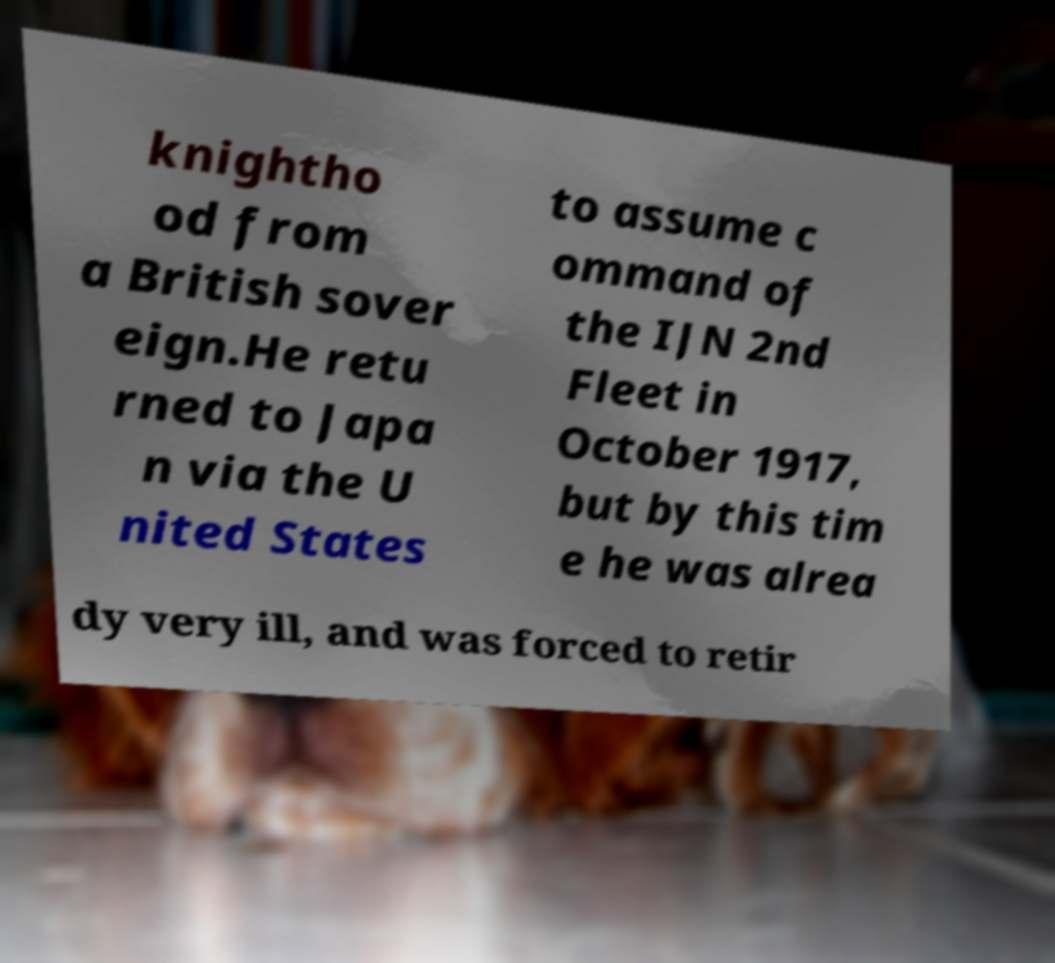For documentation purposes, I need the text within this image transcribed. Could you provide that? knightho od from a British sover eign.He retu rned to Japa n via the U nited States to assume c ommand of the IJN 2nd Fleet in October 1917, but by this tim e he was alrea dy very ill, and was forced to retir 